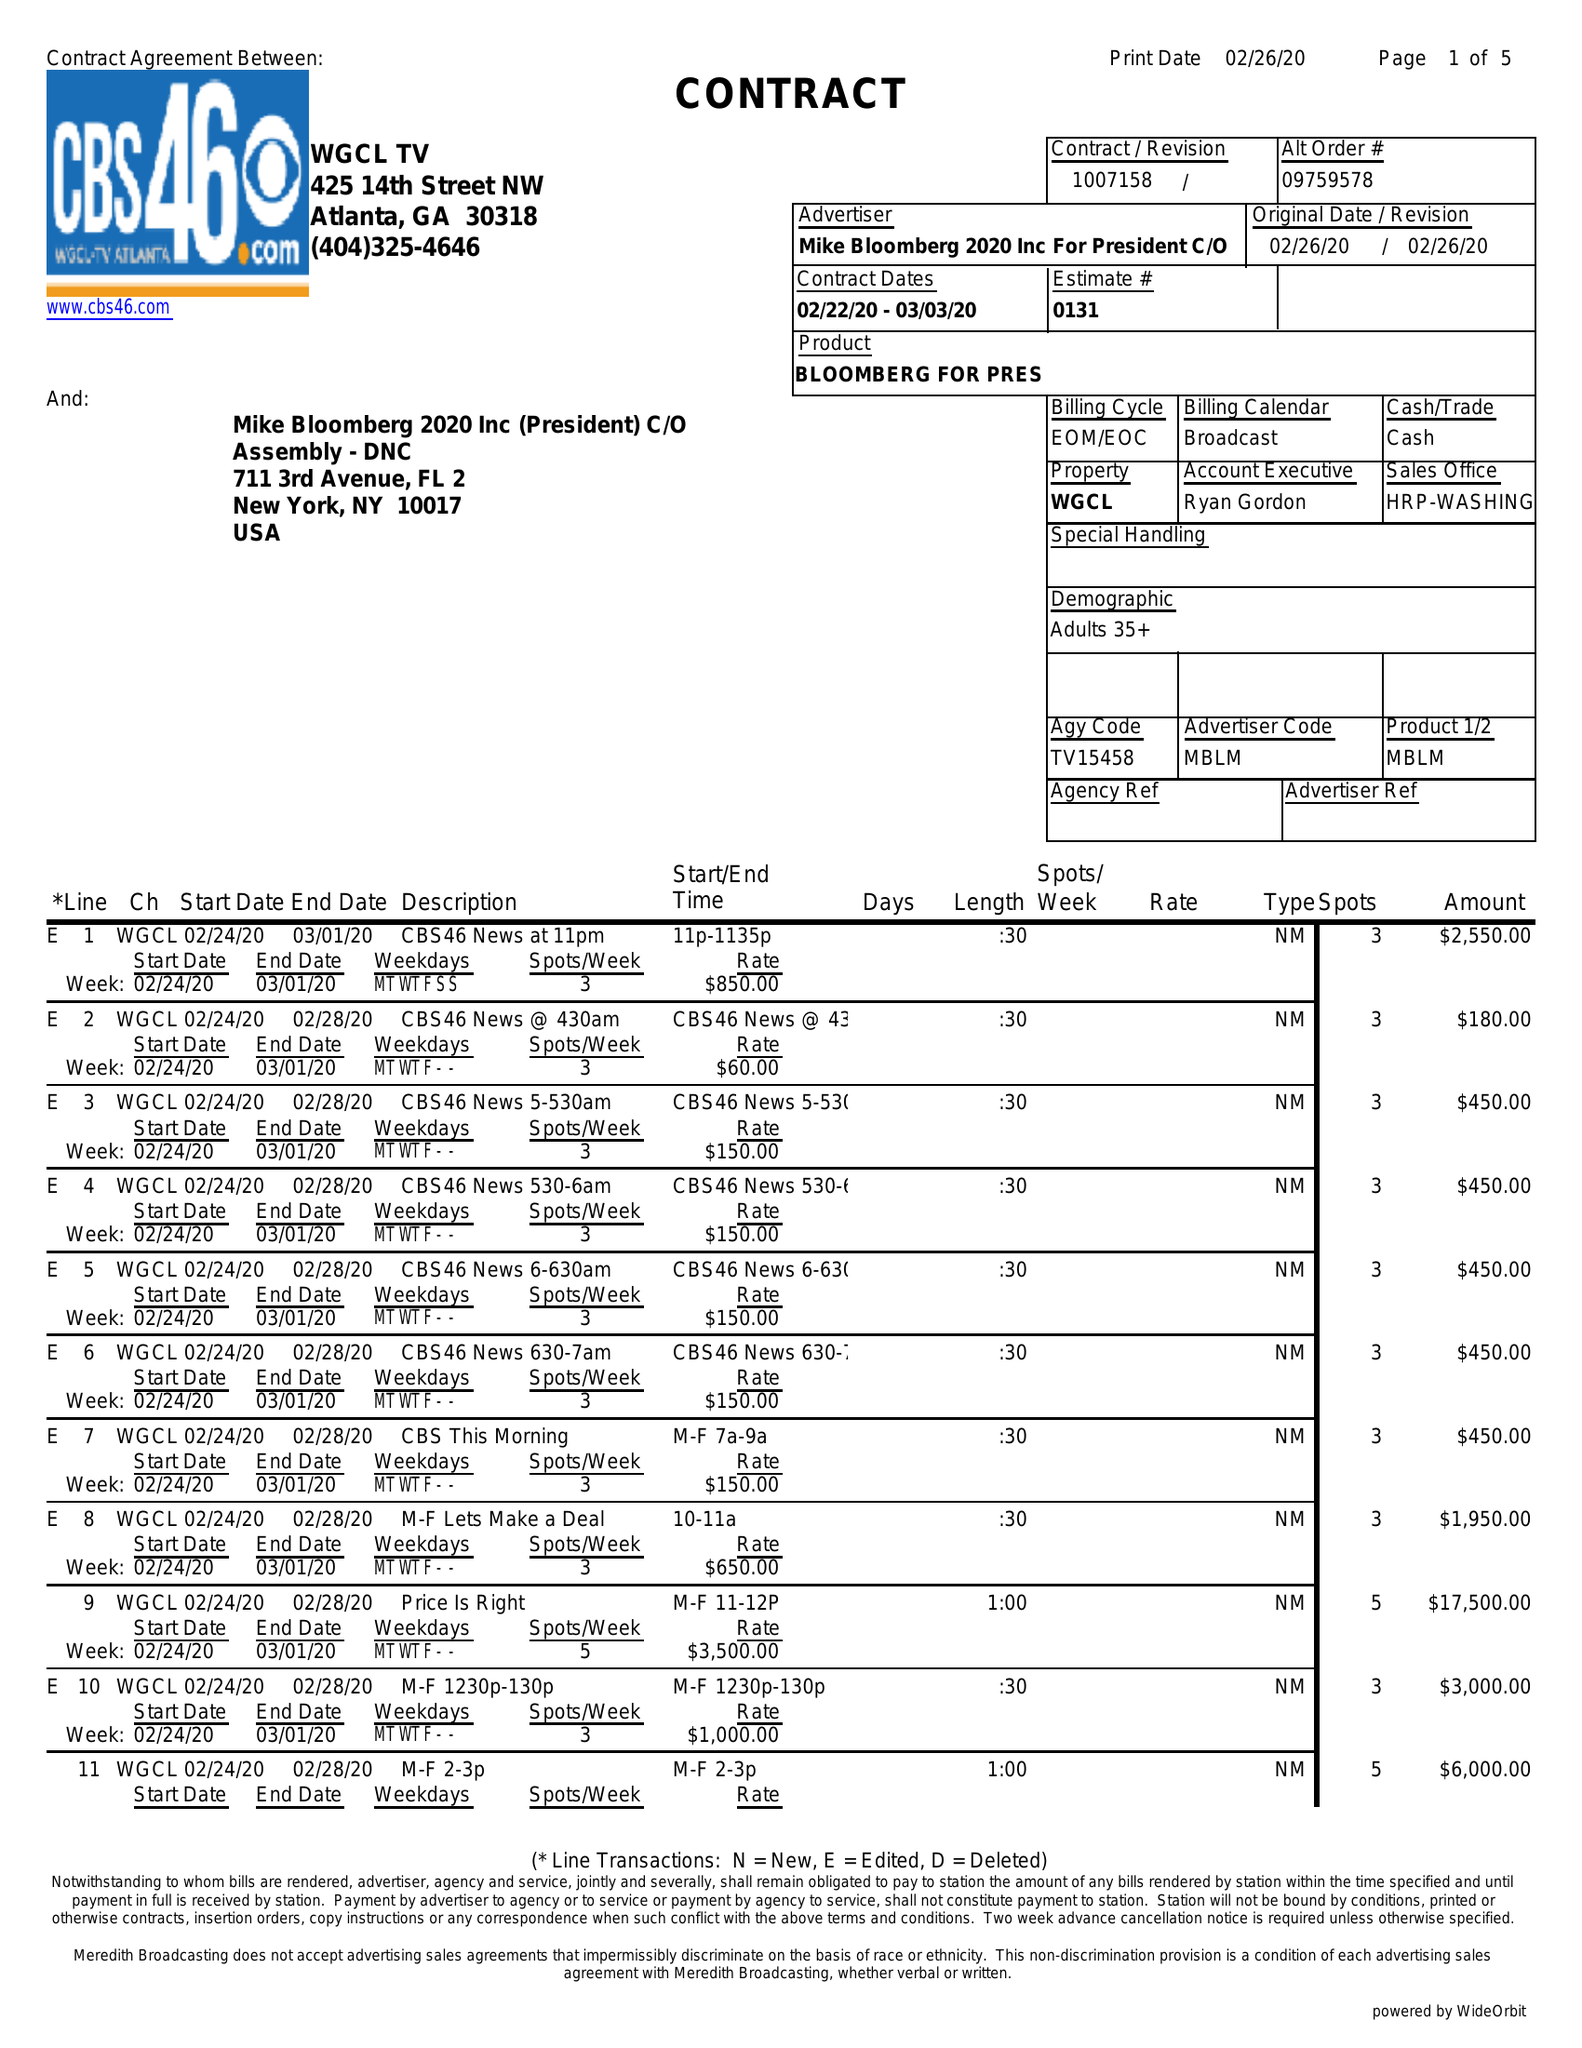What is the value for the flight_from?
Answer the question using a single word or phrase. 02/22/20 